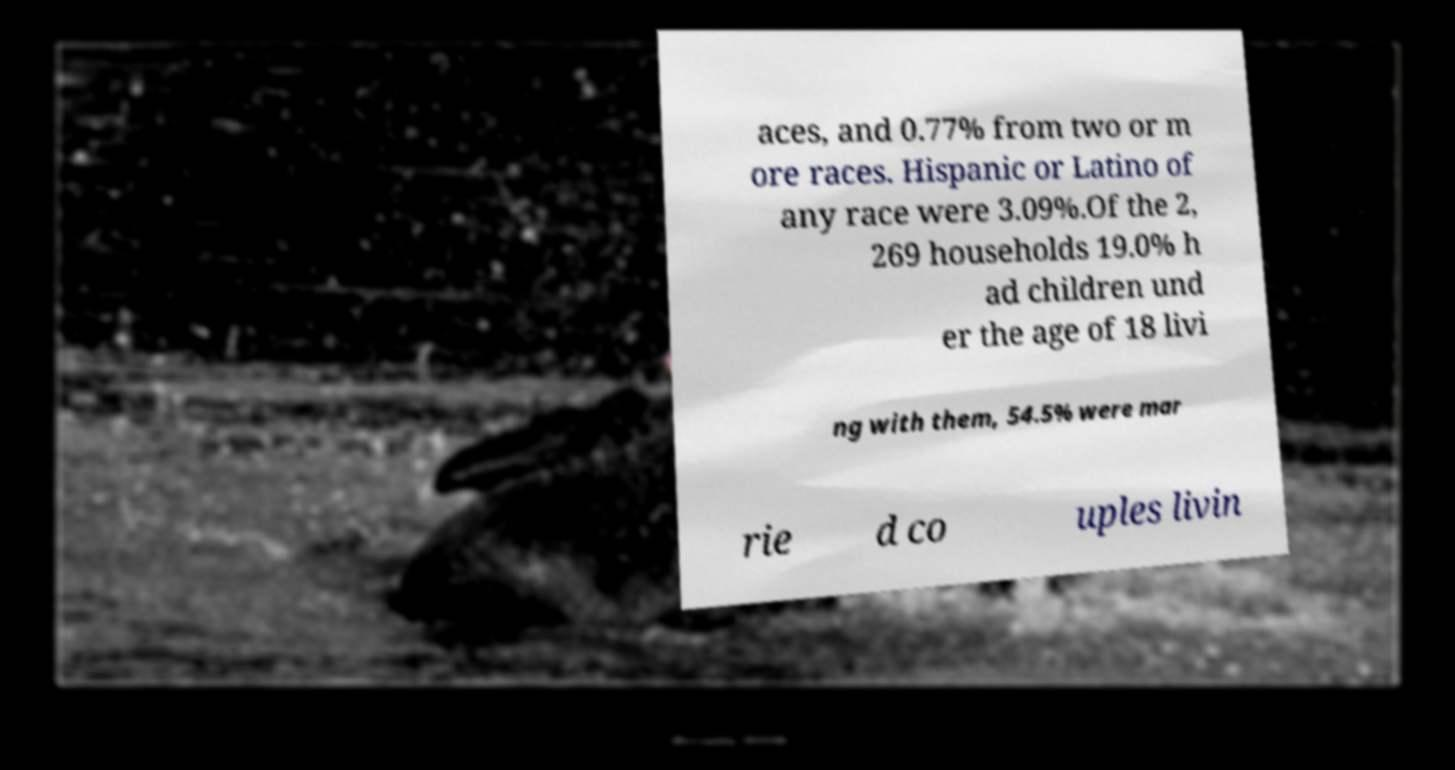Can you read and provide the text displayed in the image?This photo seems to have some interesting text. Can you extract and type it out for me? aces, and 0.77% from two or m ore races. Hispanic or Latino of any race were 3.09%.Of the 2, 269 households 19.0% h ad children und er the age of 18 livi ng with them, 54.5% were mar rie d co uples livin 